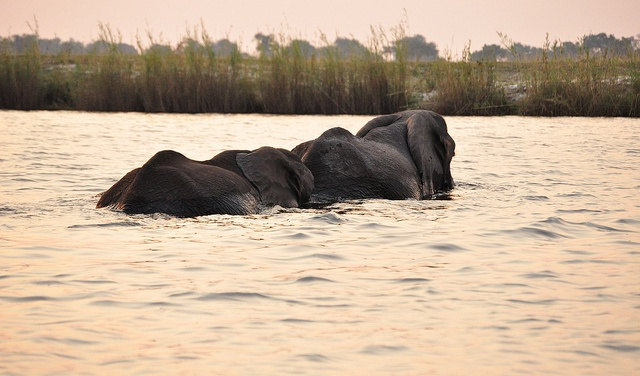Describe the objects in this image and their specific colors. I can see elephant in tan, black, and gray tones and elephant in tan, black, and gray tones in this image. 